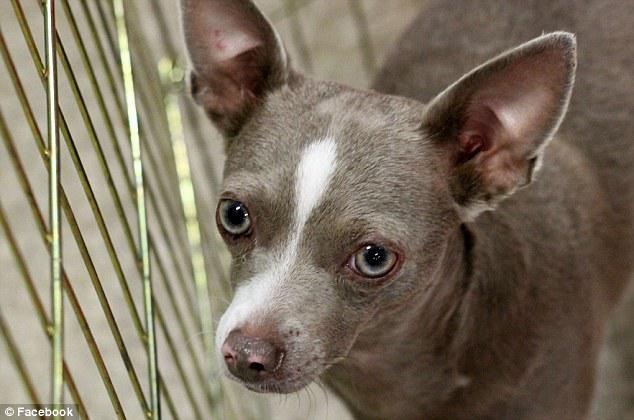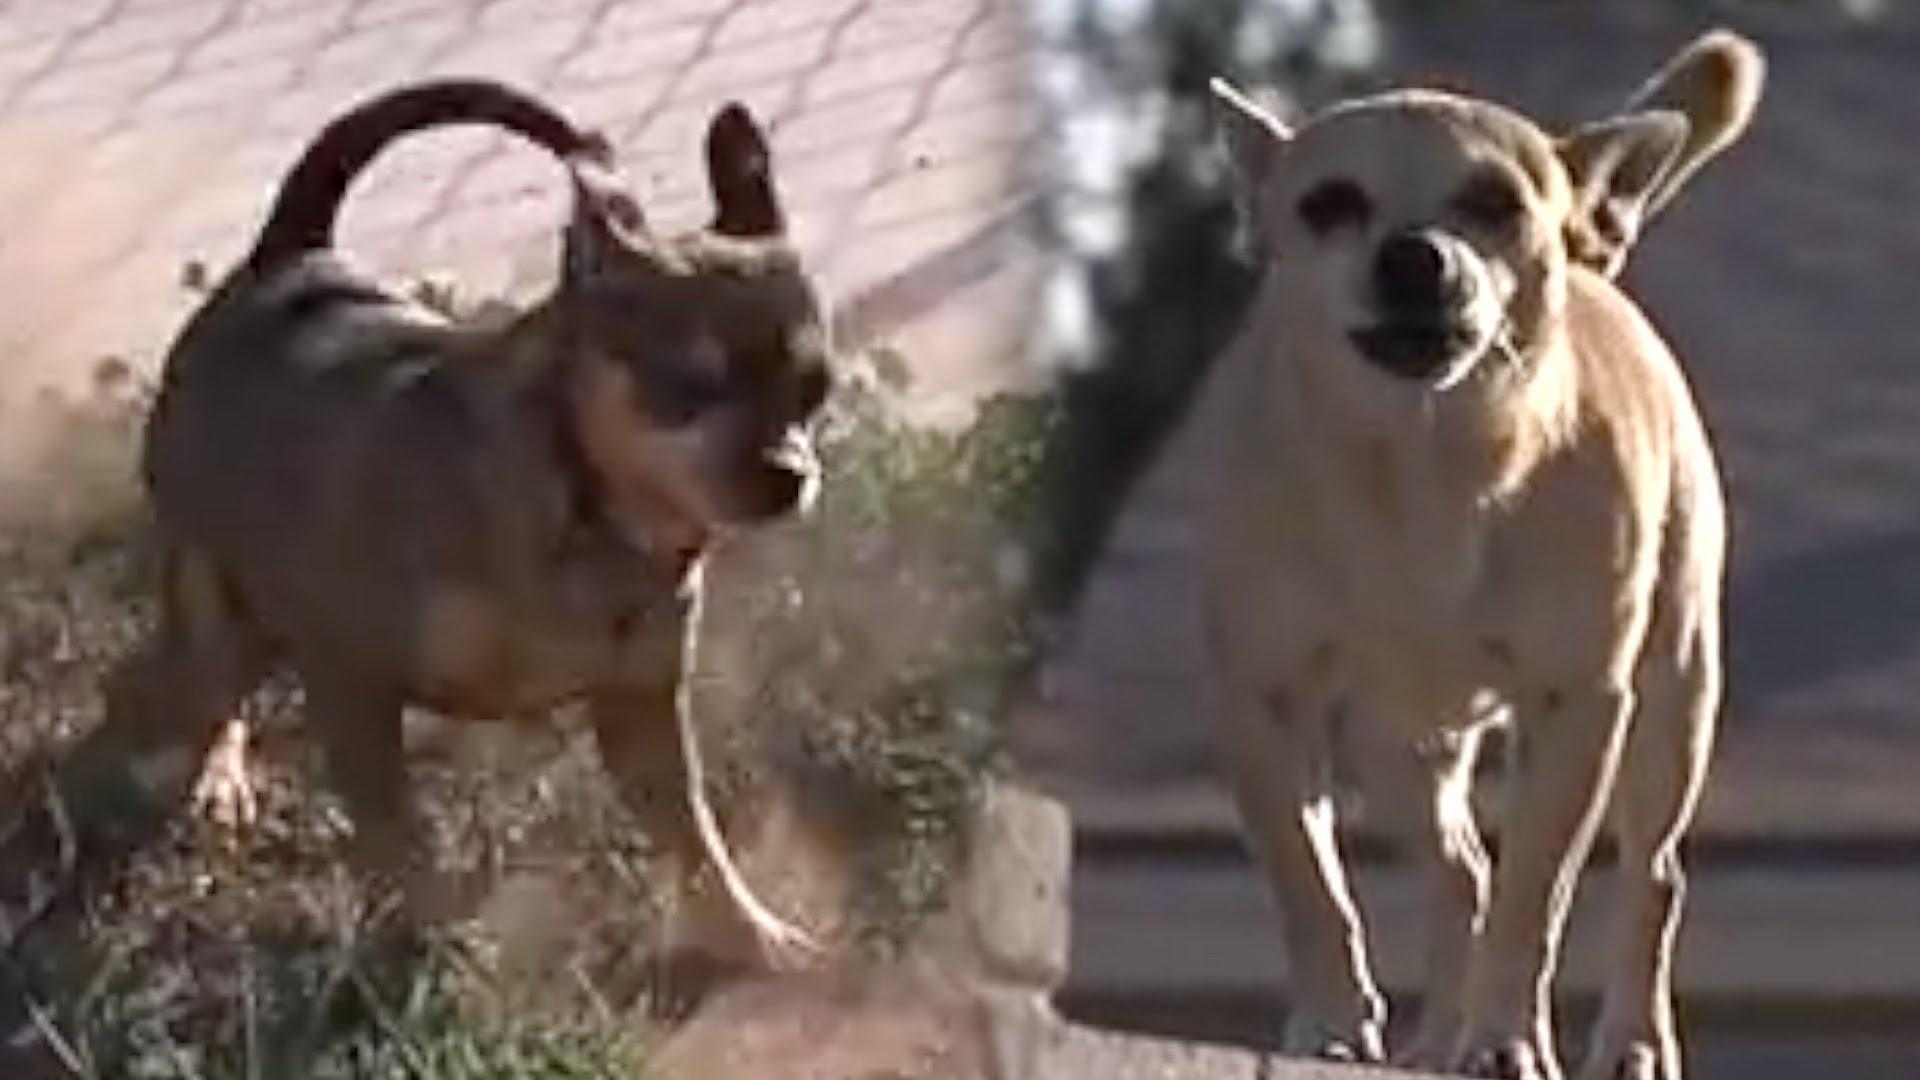The first image is the image on the left, the second image is the image on the right. Considering the images on both sides, is "At least one of the dogs is wearing a collar." valid? Answer yes or no. No. 